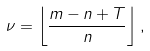Convert formula to latex. <formula><loc_0><loc_0><loc_500><loc_500>\nu = \left \lfloor \frac { m - n + T } { n } \right \rfloor ,</formula> 